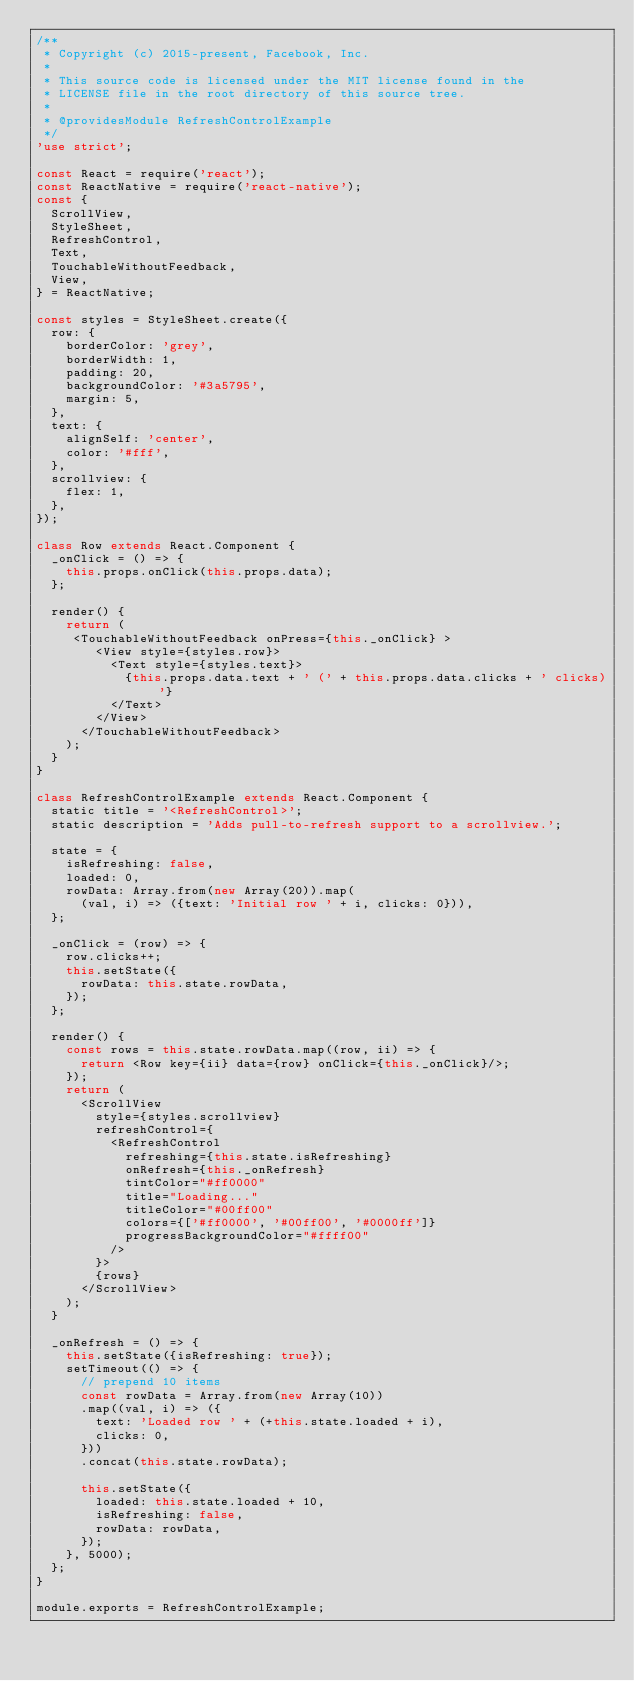<code> <loc_0><loc_0><loc_500><loc_500><_JavaScript_>/**
 * Copyright (c) 2015-present, Facebook, Inc.
 *
 * This source code is licensed under the MIT license found in the
 * LICENSE file in the root directory of this source tree.
 *
 * @providesModule RefreshControlExample
 */
'use strict';

const React = require('react');
const ReactNative = require('react-native');
const {
  ScrollView,
  StyleSheet,
  RefreshControl,
  Text,
  TouchableWithoutFeedback,
  View,
} = ReactNative;

const styles = StyleSheet.create({
  row: {
    borderColor: 'grey',
    borderWidth: 1,
    padding: 20,
    backgroundColor: '#3a5795',
    margin: 5,
  },
  text: {
    alignSelf: 'center',
    color: '#fff',
  },
  scrollview: {
    flex: 1,
  },
});

class Row extends React.Component {
  _onClick = () => {
    this.props.onClick(this.props.data);
  };

  render() {
    return (
     <TouchableWithoutFeedback onPress={this._onClick} >
        <View style={styles.row}>
          <Text style={styles.text}>
            {this.props.data.text + ' (' + this.props.data.clicks + ' clicks)'}
          </Text>
        </View>
      </TouchableWithoutFeedback>
    );
  }
}

class RefreshControlExample extends React.Component {
  static title = '<RefreshControl>';
  static description = 'Adds pull-to-refresh support to a scrollview.';

  state = {
    isRefreshing: false,
    loaded: 0,
    rowData: Array.from(new Array(20)).map(
      (val, i) => ({text: 'Initial row ' + i, clicks: 0})),
  };

  _onClick = (row) => {
    row.clicks++;
    this.setState({
      rowData: this.state.rowData,
    });
  };

  render() {
    const rows = this.state.rowData.map((row, ii) => {
      return <Row key={ii} data={row} onClick={this._onClick}/>;
    });
    return (
      <ScrollView
        style={styles.scrollview}
        refreshControl={
          <RefreshControl
            refreshing={this.state.isRefreshing}
            onRefresh={this._onRefresh}
            tintColor="#ff0000"
            title="Loading..."
            titleColor="#00ff00"
            colors={['#ff0000', '#00ff00', '#0000ff']}
            progressBackgroundColor="#ffff00"
          />
        }>
        {rows}
      </ScrollView>
    );
  }

  _onRefresh = () => {
    this.setState({isRefreshing: true});
    setTimeout(() => {
      // prepend 10 items
      const rowData = Array.from(new Array(10))
      .map((val, i) => ({
        text: 'Loaded row ' + (+this.state.loaded + i),
        clicks: 0,
      }))
      .concat(this.state.rowData);

      this.setState({
        loaded: this.state.loaded + 10,
        isRefreshing: false,
        rowData: rowData,
      });
    }, 5000);
  };
}

module.exports = RefreshControlExample;
</code> 